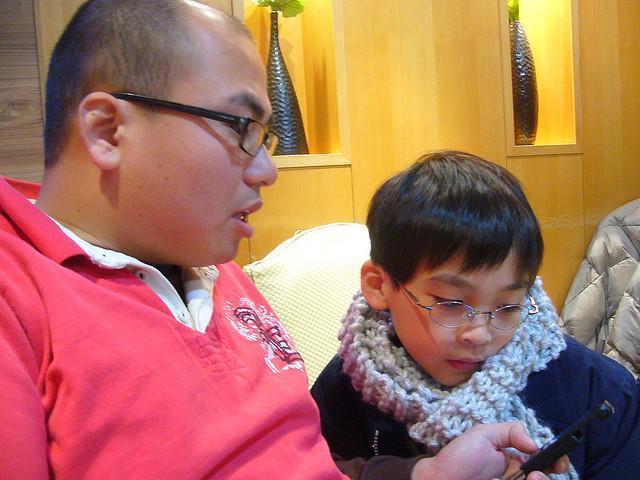How many people have glasses?
Give a very brief answer. 2. How many people can you see?
Give a very brief answer. 2. How many couches can be seen?
Give a very brief answer. 2. How many vases are visible?
Give a very brief answer. 2. 